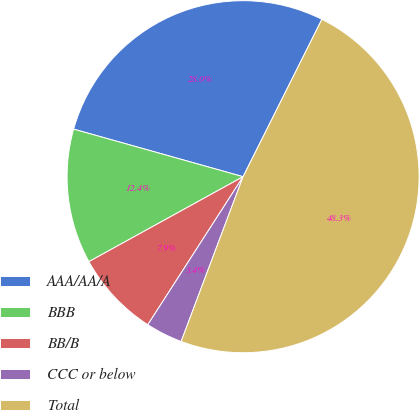Convert chart. <chart><loc_0><loc_0><loc_500><loc_500><pie_chart><fcel>AAA/AA/A<fcel>BBB<fcel>BB/B<fcel>CCC or below<fcel>Total<nl><fcel>28.03%<fcel>12.37%<fcel>7.88%<fcel>3.38%<fcel>48.33%<nl></chart> 